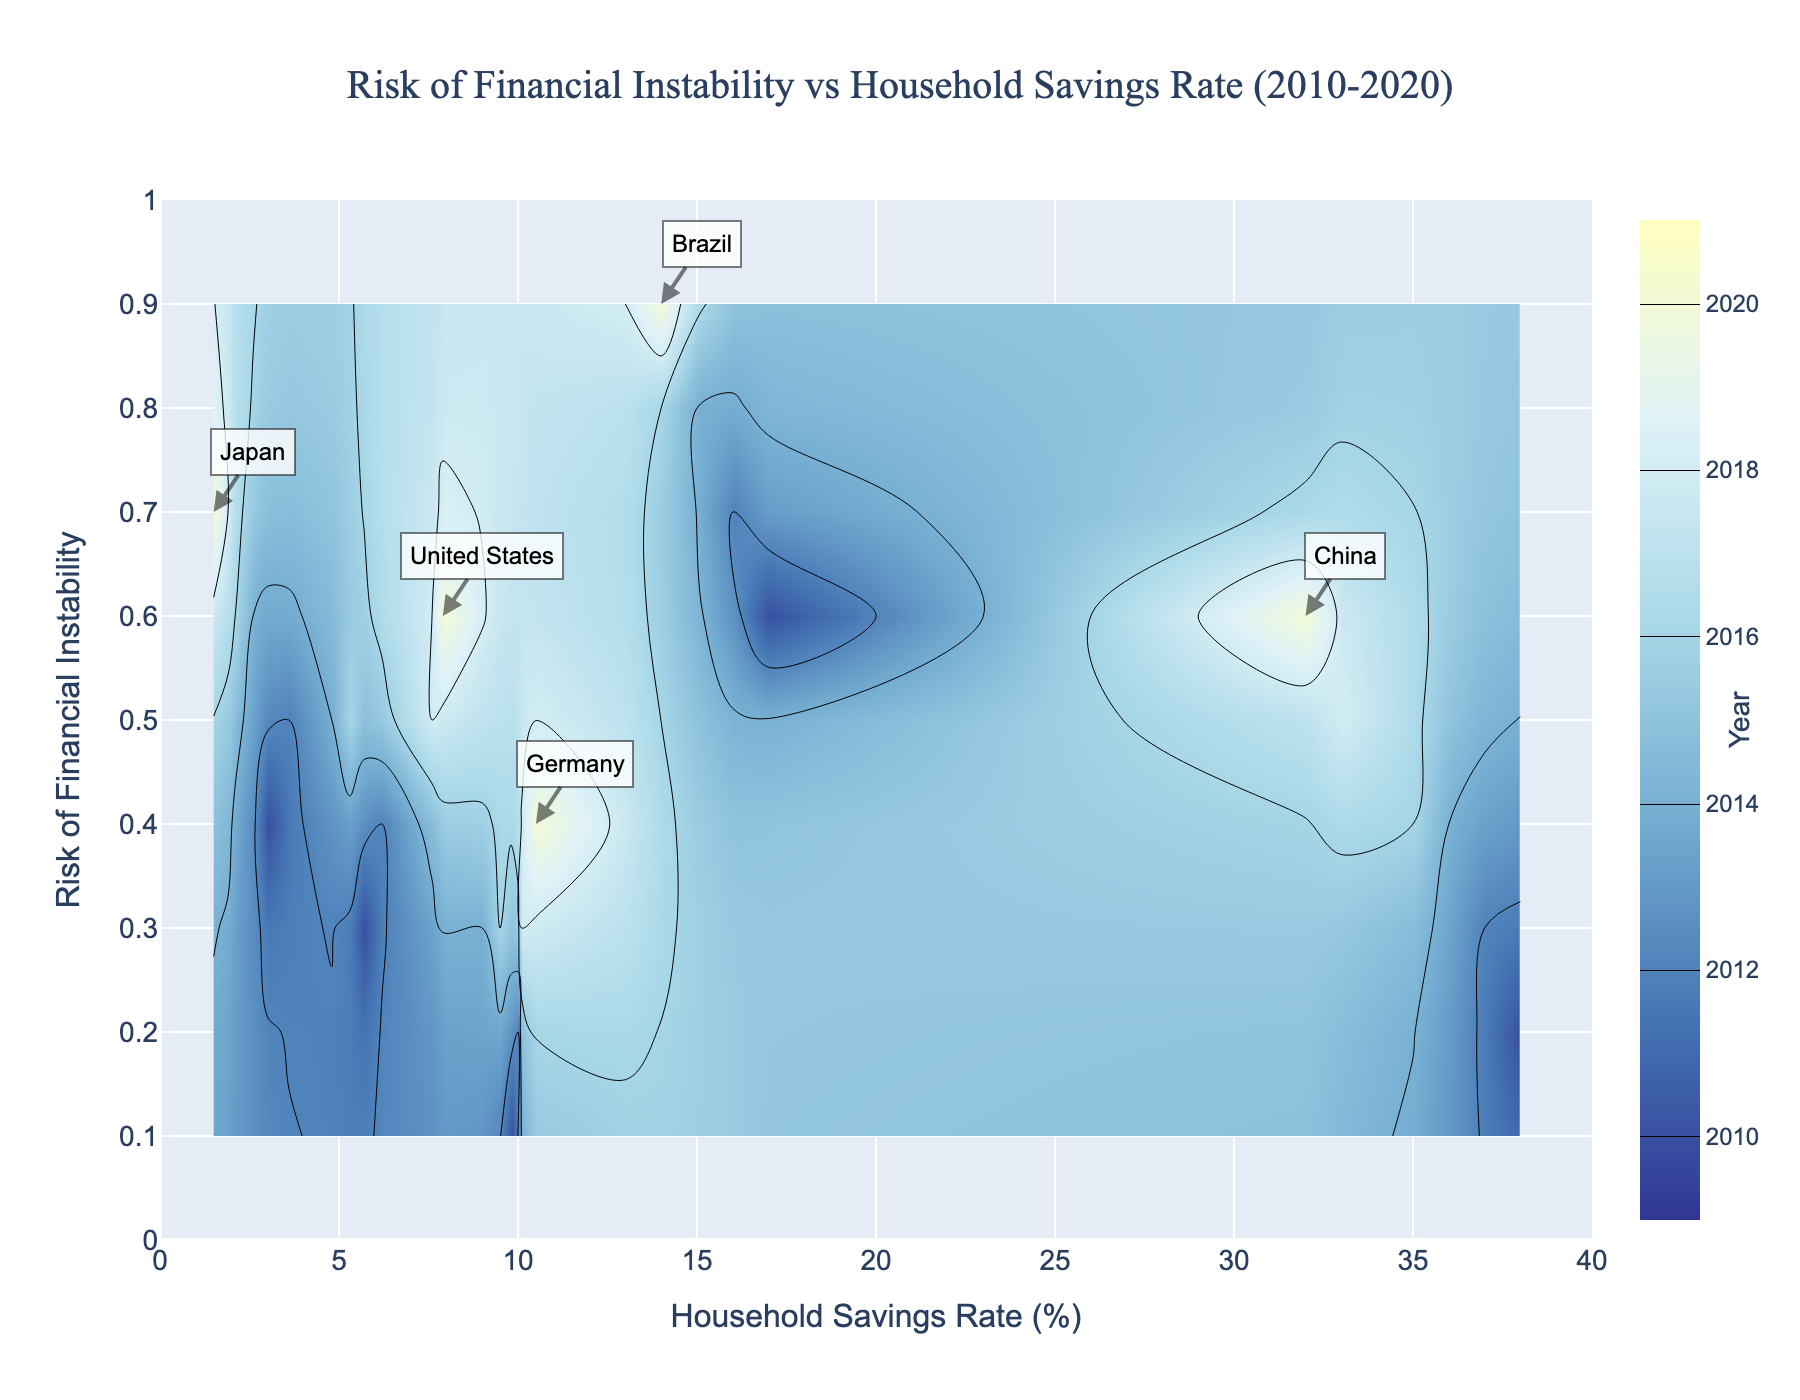What's the title of the figure? The title is located at the top center of the figure and reads "Risk of Financial Instability vs Household Savings Rate (2010-2020)".
Answer: Risk of Financial Instability vs Household Savings Rate (2010-2020) What's the range of the x-axis? The x-axis range can be seen at the bottom of the figure, marked from 0 to 40 with a step size of 5.
Answer: 0 to 40 Which country has the highest household savings rate in 2020? The annotation for China is located at a household savings rate of 32%, which is the highest on the x-axis for 2020.
Answer: China What's the color indicating the year 2018 in the contour plot? The color scale on the right side of the plot links the year 2018 to a light blue color.
Answer: Light blue How does the household savings rate in the United States change from 2010 to 2020? Refer to the plotted points for the United States: 2010 (5.7%), 2012 (6.2%), 2014 (4.8%), 2016 (5.3%), 2018 (7.6%), and 2020 (7.9%). The rate generally increases with minor fluctuations.
Answer: Generally increases Compare the risk of financial instability between Japan and Brazil in 2020. In the 2020 annotations, Japan is at a risk of 0.7, while Brazil is at 0.9. Brazil has a higher risk of financial instability.
Answer: Brazil has a higher risk Which year shows the highest average household savings rate among the countries listed? Calculate the average savings rate for each year. For instance, 2020: (7.9+10.5+1.5+32.0+14.0)=65.9/5=13.18. Repeat this for other years. The year with the highest average rate is 2010.
Answer: 2010 Does the risk of financial instability generally increase or decrease as household savings rates increase? Observing the plot, most country points tend to show lower risks (lower y-values) with higher savings rates (rightward x-values).
Answer: Decrease Which country has the highest risk of financial instability, and what is their savings rate in 2020? The annotation for Brazil (2020) shows it has the highest risk at 0.9 with a savings rate of 14%.
Answer: Brazil, 14% Compare the color assigned to the year 2012 with that of 2014. The year 2012 is mapped to a slightly darker blue compared to the lighter blue color assigned to 2014, as observed in the color scale on the right.
Answer: Slightly darker blue (2012) vs. lighter blue (2014) 